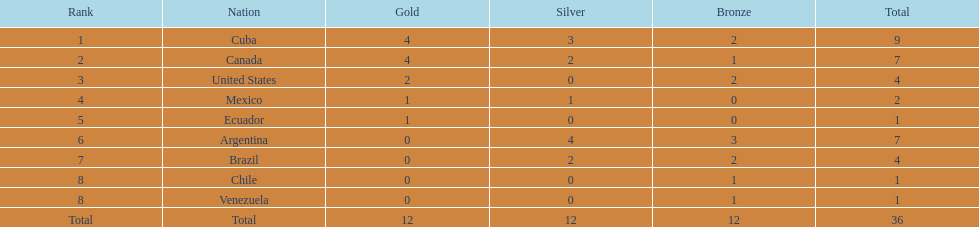Between cuba and brazil, which country had a greater number of silver medals? Cuba. 